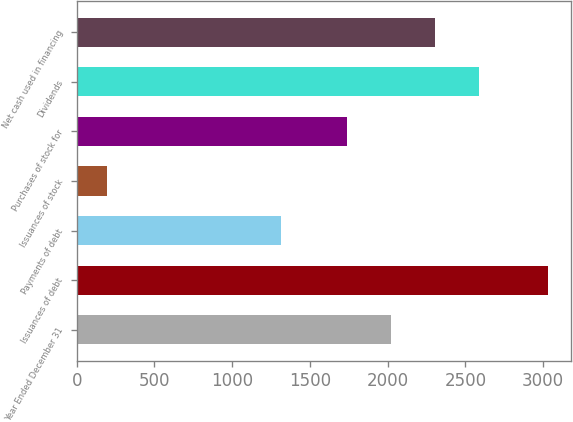<chart> <loc_0><loc_0><loc_500><loc_500><bar_chart><fcel>Year Ended December 31<fcel>Issuances of debt<fcel>Payments of debt<fcel>Issuances of stock<fcel>Purchases of stock for<fcel>Dividends<fcel>Net cash used in financing<nl><fcel>2022.7<fcel>3030<fcel>1316<fcel>193<fcel>1739<fcel>2590.1<fcel>2306.4<nl></chart> 